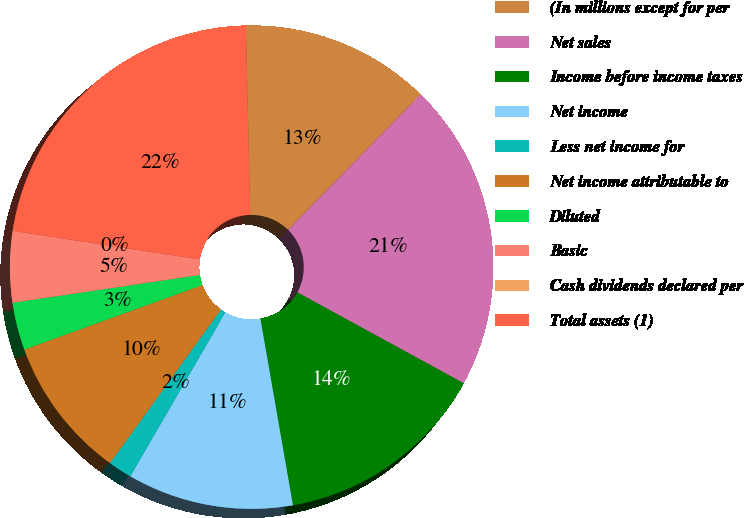Convert chart to OTSL. <chart><loc_0><loc_0><loc_500><loc_500><pie_chart><fcel>(In millions except for per<fcel>Net sales<fcel>Income before income taxes<fcel>Net income<fcel>Less net income for<fcel>Net income attributable to<fcel>Diluted<fcel>Basic<fcel>Cash dividends declared per<fcel>Total assets (1)<nl><fcel>12.7%<fcel>20.63%<fcel>14.29%<fcel>11.11%<fcel>1.59%<fcel>9.52%<fcel>3.18%<fcel>4.76%<fcel>0.0%<fcel>22.22%<nl></chart> 